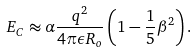<formula> <loc_0><loc_0><loc_500><loc_500>E _ { C } \approx \alpha \frac { q ^ { 2 } } { 4 \pi \epsilon R _ { o } } \left ( 1 - \frac { 1 } { 5 } \beta ^ { 2 } \right ) .</formula> 